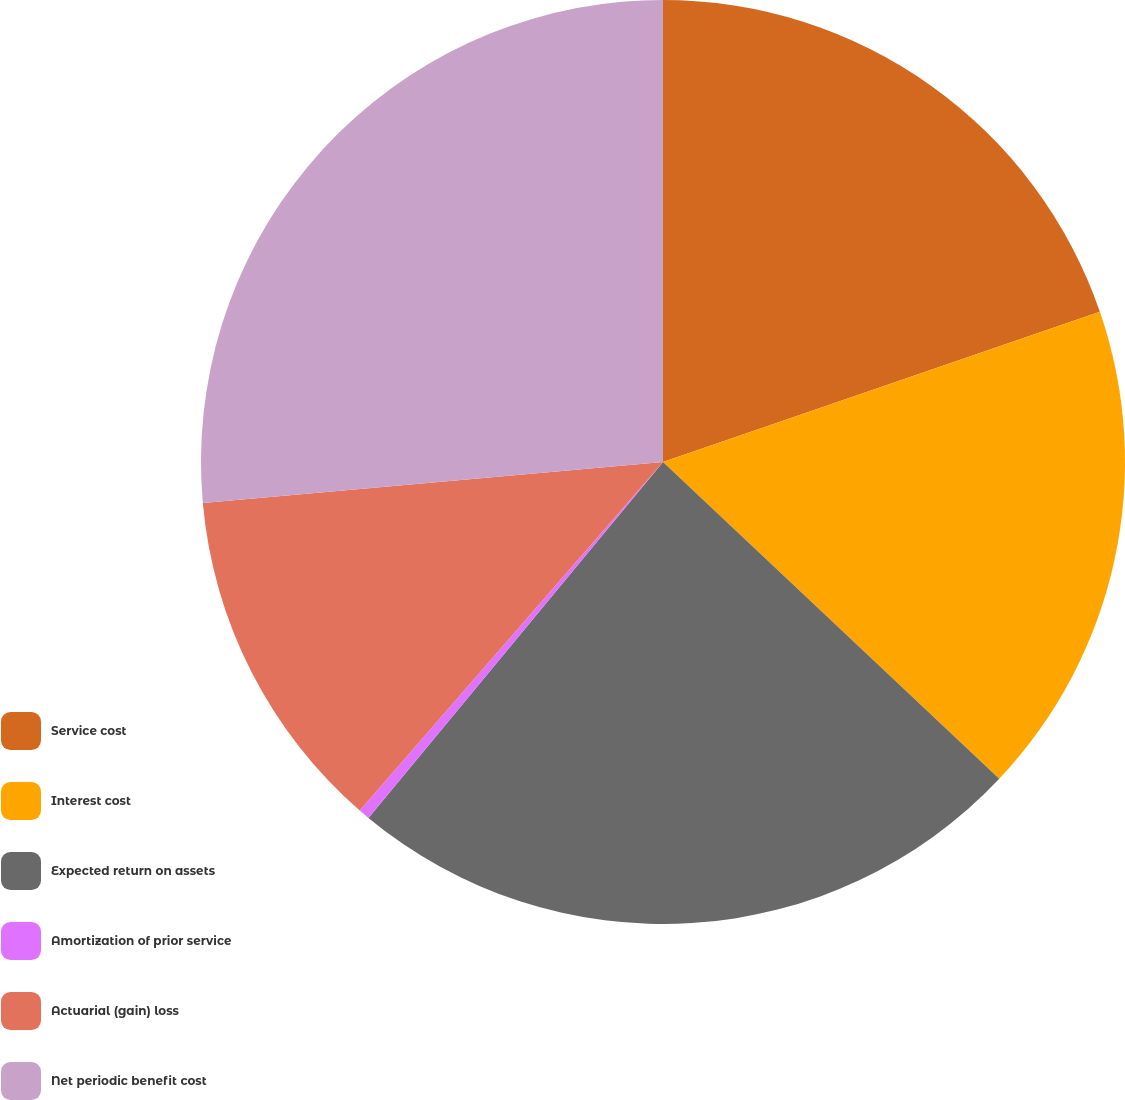Convert chart to OTSL. <chart><loc_0><loc_0><loc_500><loc_500><pie_chart><fcel>Service cost<fcel>Interest cost<fcel>Expected return on assets<fcel>Amortization of prior service<fcel>Actuarial (gain) loss<fcel>Net periodic benefit cost<nl><fcel>19.73%<fcel>17.3%<fcel>23.98%<fcel>0.39%<fcel>12.19%<fcel>26.42%<nl></chart> 